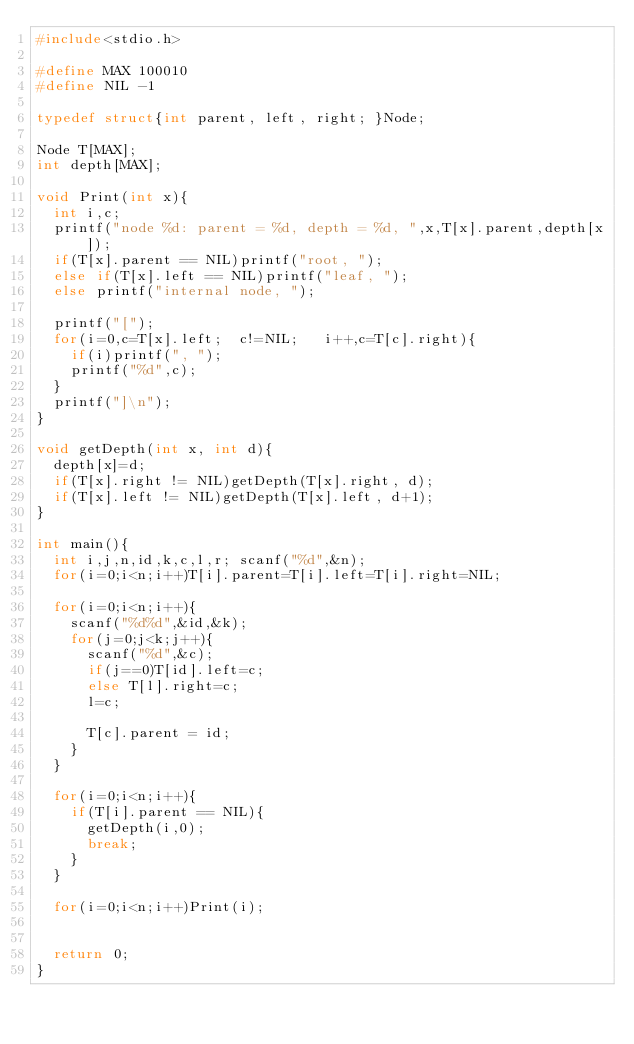<code> <loc_0><loc_0><loc_500><loc_500><_C_>#include<stdio.h>

#define MAX 100010
#define NIL -1

typedef struct{int parent, left, right; }Node;

Node T[MAX];
int depth[MAX];

void Print(int x){
	int i,c;
	printf("node %d: parent = %d, depth = %d, ",x,T[x].parent,depth[x]);
	if(T[x].parent == NIL)printf("root, ");
	else if(T[x].left == NIL)printf("leaf, ");
	else printf("internal node, ");

	printf("[");
	for(i=0,c=T[x].left;	c!=NIL;		i++,c=T[c].right){
		if(i)printf(", ");
		printf("%d",c);
	}
	printf("]\n");
}

void getDepth(int x, int d){
	depth[x]=d;
	if(T[x].right != NIL)getDepth(T[x].right, d);
	if(T[x].left != NIL)getDepth(T[x].left, d+1);
}

int main(){
	int i,j,n,id,k,c,l,r;	scanf("%d",&n);
	for(i=0;i<n;i++)T[i].parent=T[i].left=T[i].right=NIL;

	for(i=0;i<n;i++){
		scanf("%d%d",&id,&k);
		for(j=0;j<k;j++){
			scanf("%d",&c);
			if(j==0)T[id].left=c;
			else T[l].right=c;
			l=c;

			T[c].parent = id;
		}
	}

	for(i=0;i<n;i++){
		if(T[i].parent == NIL){
			getDepth(i,0);
			break;
		}
	}

	for(i=0;i<n;i++)Print(i);


	return 0;
}

</code> 